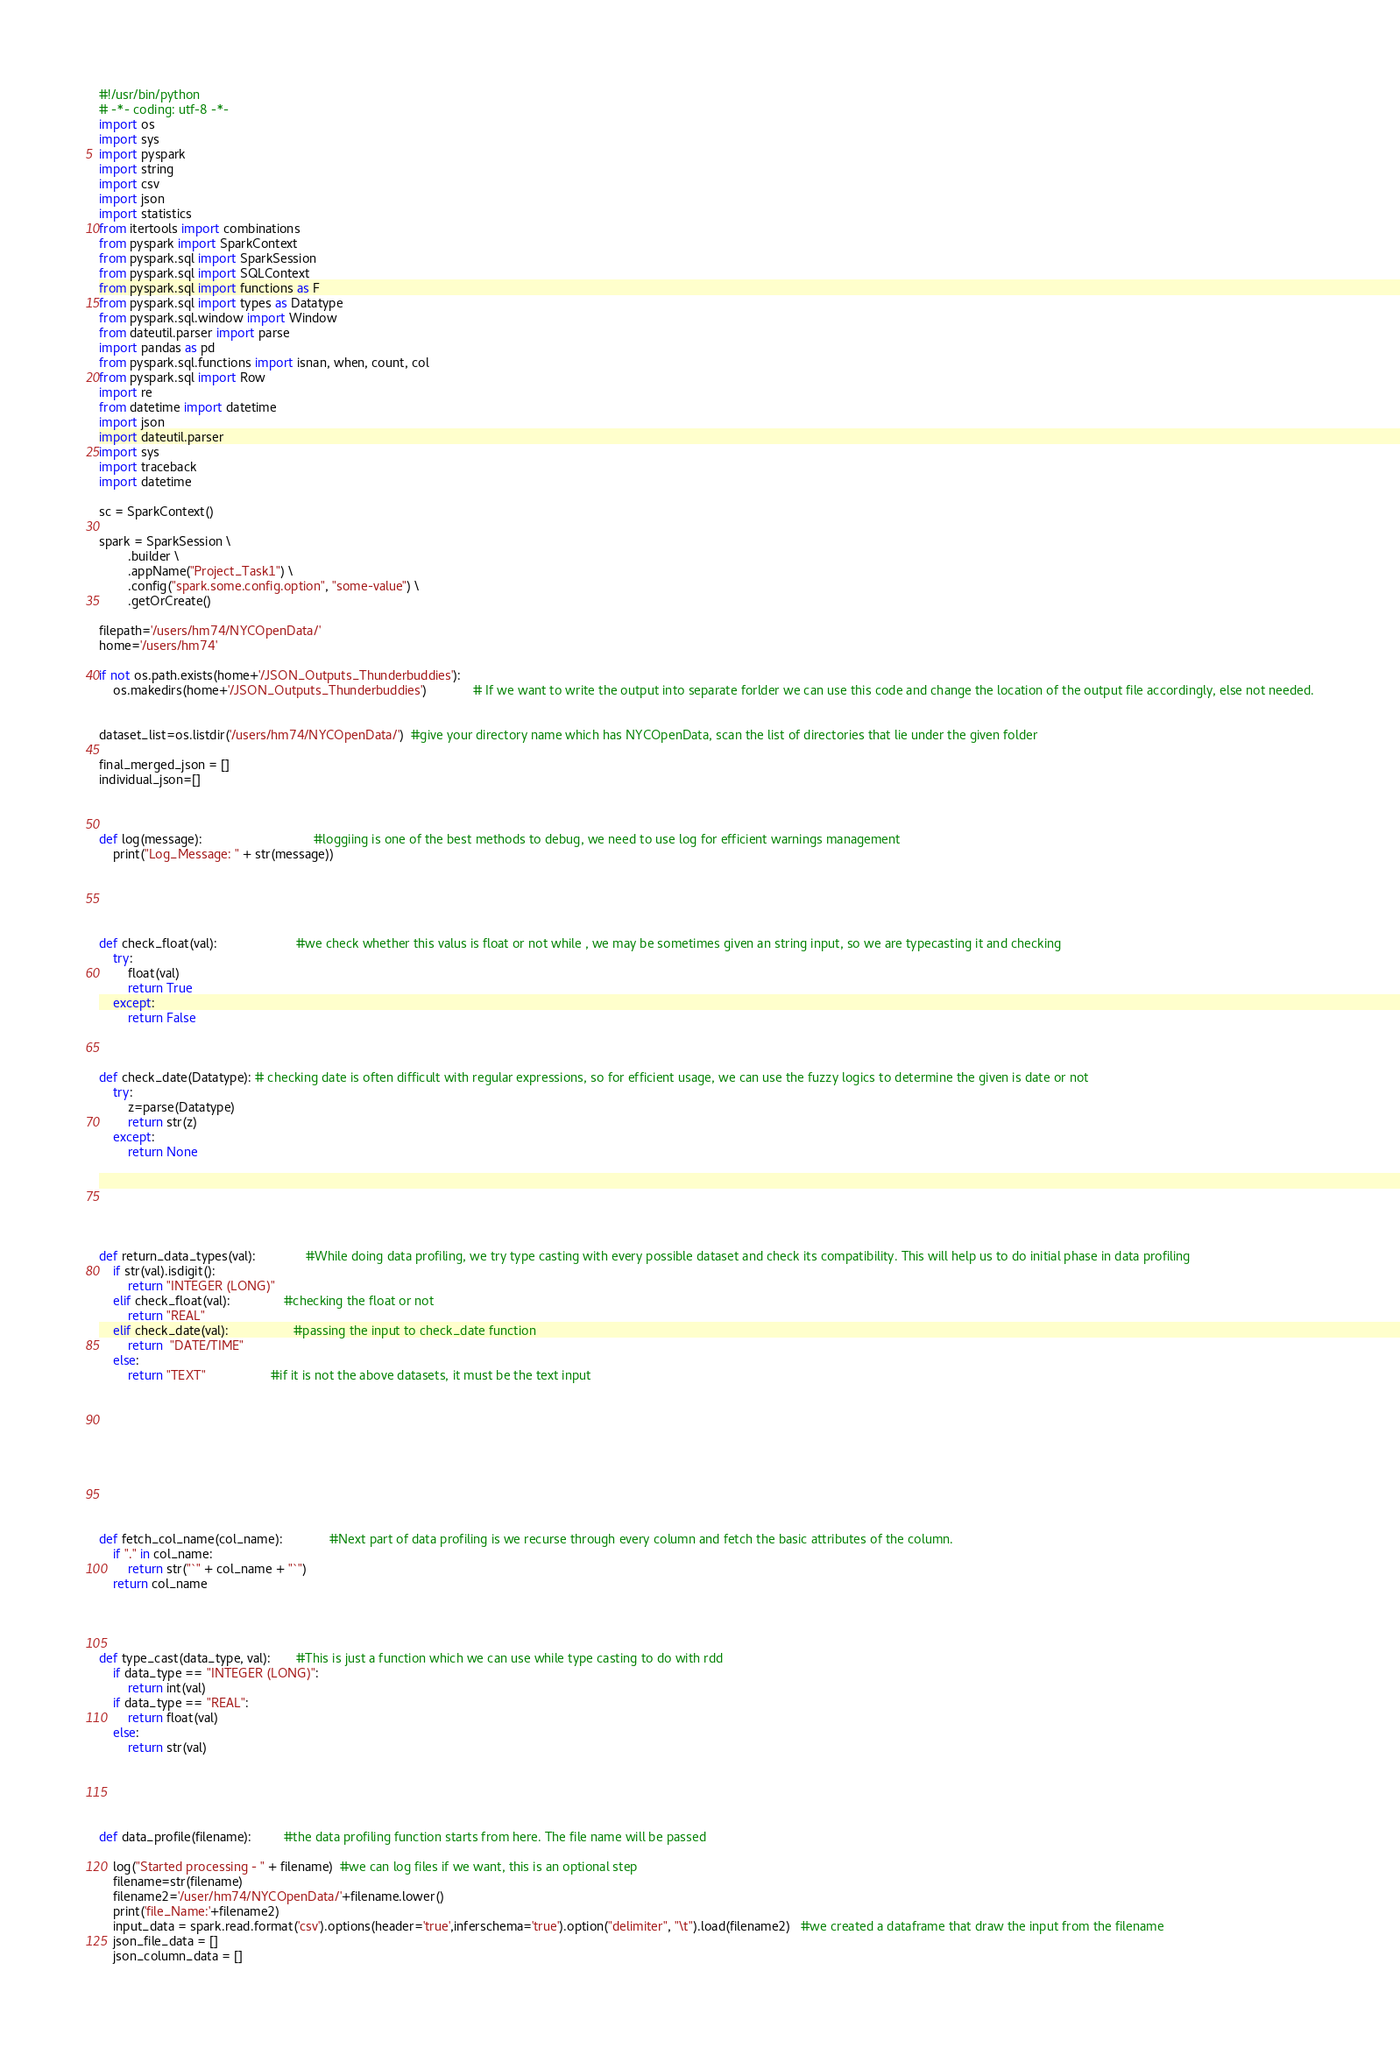<code> <loc_0><loc_0><loc_500><loc_500><_Python_>#!/usr/bin/python
# -*- coding: utf-8 -*-
import os  
import sys
import pyspark
import string
import csv
import json
import statistics
from itertools import combinations
from pyspark import SparkContext
from pyspark.sql import SparkSession
from pyspark.sql import SQLContext
from pyspark.sql import functions as F
from pyspark.sql import types as Datatype
from pyspark.sql.window import Window
from dateutil.parser import parse
import pandas as pd
from pyspark.sql.functions import isnan, when, count, col
from pyspark.sql import Row
import re
from datetime import datetime
import json
import dateutil.parser
import sys
import traceback
import datetime

sc = SparkContext()

spark = SparkSession \
        .builder \
        .appName("Project_Task1") \
        .config("spark.some.config.option", "some-value") \
        .getOrCreate()

filepath='/users/hm74/NYCOpenData/'
home='/users/hm74'

if not os.path.exists(home+'/JSON_Outputs_Thunderbuddies'):
    os.makedirs(home+'/JSON_Outputs_Thunderbuddies')             # If we want to write the output into separate forlder we can use this code and change the location of the output file accordingly, else not needed.


dataset_list=os.listdir('/users/hm74/NYCOpenData/')  #give your directory name which has NYCOpenData, scan the list of directories that lie under the given folder        

final_merged_json = []
individual_json=[]
      
        
        
def log(message):                               #loggiing is one of the best methods to debug, we need to use log for efficient warnings management
    print("Log_Message: " + str(message))





def check_float(val):                      #we check whether this valus is float or not while , we may be sometimes given an string input, so we are typecasting it and checking 
    try:
        float(val)
        return True
    except:
        return False



def check_date(Datatype): # checking date is often difficult with regular expressions, so for efficient usage, we can use the fuzzy logics to determine the given is date or not 
    try:
        z=parse(Datatype)
        return str(z)
    except:
        return None






def return_data_types(val):              #While doing data profiling, we try type casting with every possible dataset and check its compatibility. This will help us to do initial phase in data profiling
    if str(val).isdigit():
        return "INTEGER (LONG)"
    elif check_float(val):               #checking the float or not
        return "REAL"
    elif check_date(val):                  #passing the input to check_date function
        return  "DATE/TIME"
    else:
        return "TEXT"                  #if it is not the above datasets, it must be the text input










def fetch_col_name(col_name):             #Next part of data profiling is we recurse through every column and fetch the basic attributes of the column.
    if "." in col_name:
        return str("`" + col_name + "`")
    return col_name




def type_cast(data_type, val):       #This is just a function which we can use while type casting to do with rdd
    if data_type == "INTEGER (LONG)":
        return int(val)
    if data_type == "REAL":
        return float(val)
    else:
        return str(val)





def data_profile(filename):         #the data profiling function starts from here. The file name will be passed 
    
    log("Started processing - " + filename)  #we can log files if we want, this is an optional step
    filename=str(filename)
    filename2='/user/hm74/NYCOpenData/'+filename.lower()
    print('file_Name:'+filename2)
    input_data = spark.read.format('csv').options(header='true',inferschema='true').option("delimiter", "\t").load(filename2)   #we created a dataframe that draw the input from the filename
    json_file_data = []
    json_column_data = []    </code> 